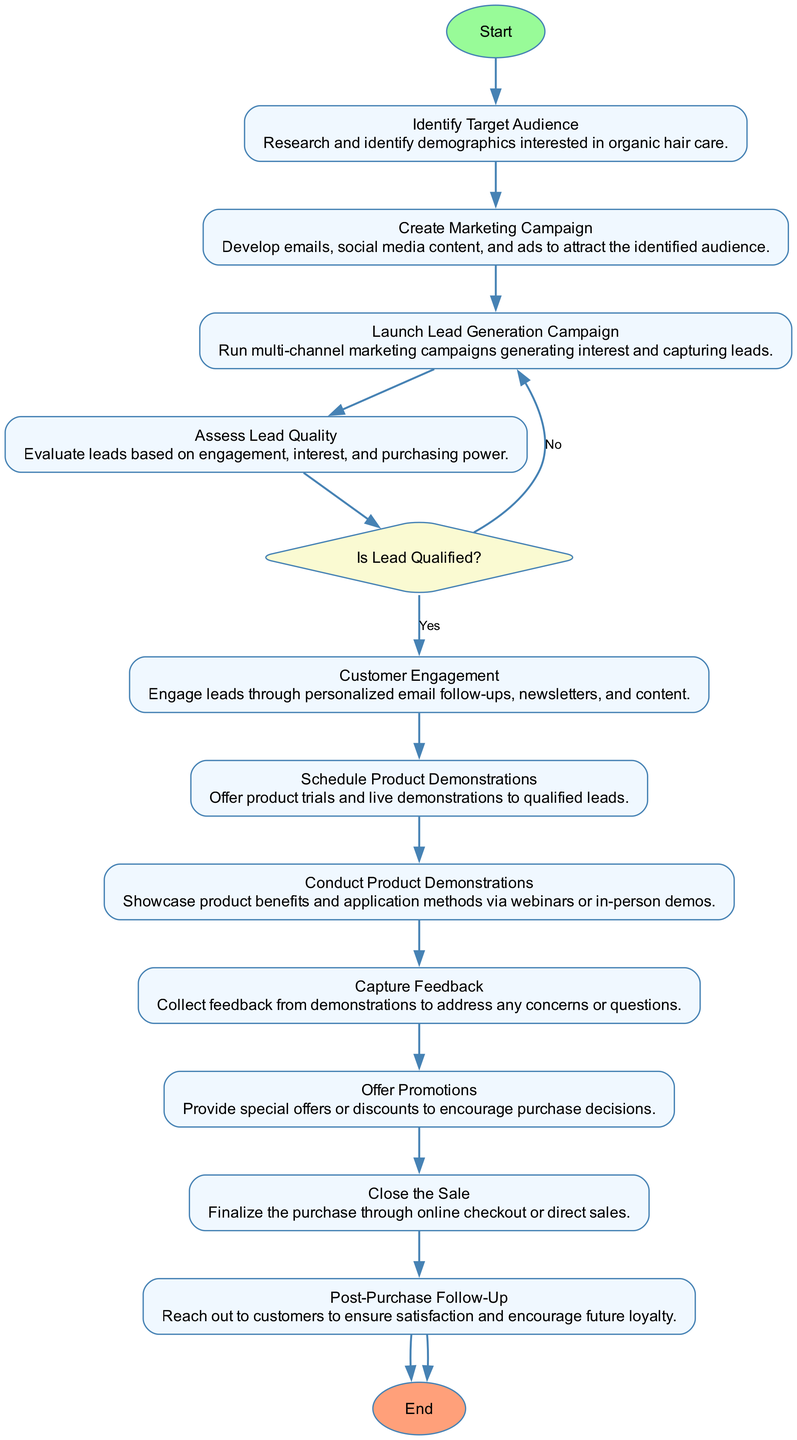What is the starting point of the process? The starting point of the process is indicated by the "Start" node, which initiates the marketing outreach.
Answer: Initiate Marketing Outreach How many activities are there in this diagram? By counting the activities listed in the diagram, we find there are 11 activities before reaching the end.
Answer: 11 What is the decision point in the process? The decision point is found in the "Assess Lead Quality" activity where it asks "Is Lead Qualified?".
Answer: Is Lead Qualified? What activity follows "Schedule Product Demonstrations"? The next activity after "Schedule Product Demonstrations" is "Conduct Product Demonstrations".
Answer: Conduct Product Demonstrations What is the final activity in the process? The final activity before completing the process is "Post-Purchase Follow-Up".
Answer: Post-Purchase Follow-Up What activity provides special offers? The activity that provides special offers is "Offer Promotions".
Answer: Offer Promotions If a lead is not qualified, which activity does the process loop back to? If a lead is not qualified, the process loops back to the "Launch Lead Generation Campaign" activity.
Answer: Launch Lead Generation Campaign How does the process conclude? The process concludes at the "End" node after the activity "Post-Purchase Follow-Up".
Answer: Process Completed What type of feedback is collected after product demonstrations? The feedback collected after product demonstrations is used to address any concerns or questions from the leads.
Answer: Capture Feedback How does customer engagement occur? Customer engagement occurs through personalized email follow-ups, newsletters, and content sharing.
Answer: Customer Engagement 